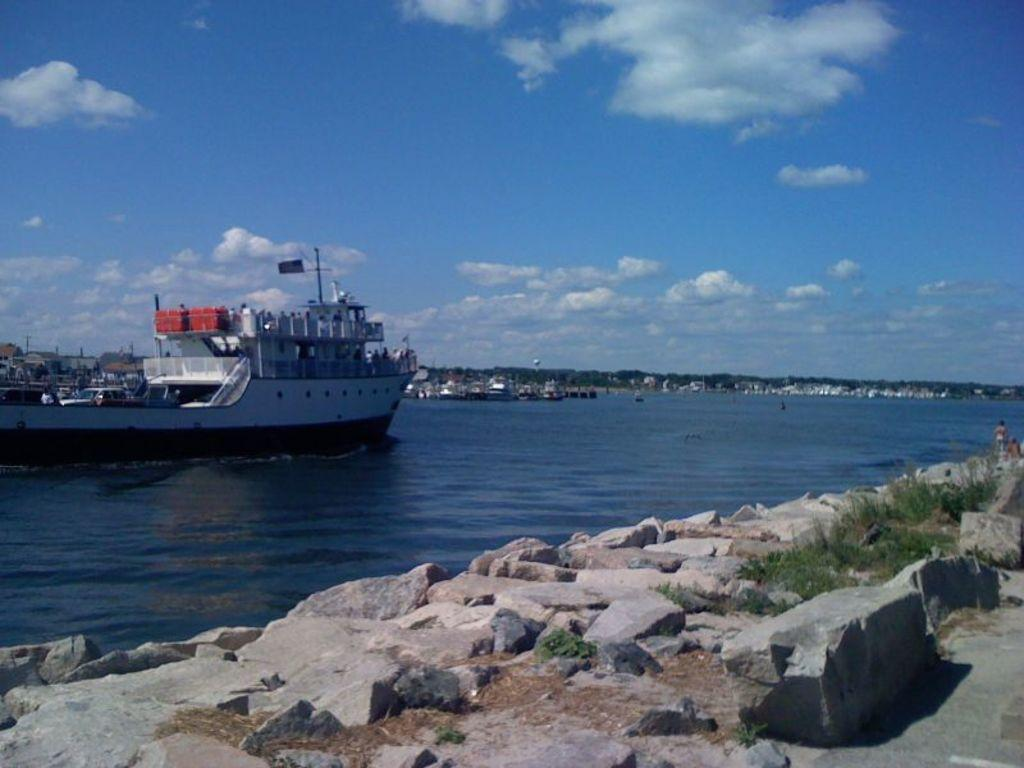What can be seen in the foreground of the image? There are rocks in the foreground of the image. Where are the rocks located in relation to other elements in the image? The rocks are located near a road. What is visible in the background of the image? In the background, there is a ship on water, greenery, buildings, and the sky with clouds. Can you describe the ship in the image? The ship is visible in the background, and it is on water. What is the condition of the sky in the image? The sky is visible in the background of the image, and there are clouds present. What type of organization is represented by the cloud in the image? There is no organization represented by a cloud in the image, as clouds are natural phenomena and not associated with any organization. Can you describe the line that connects the rocks to the ship in the image? There is no line connecting the rocks to the ship in the image; the rocks and the ship are separate elements in the image. 